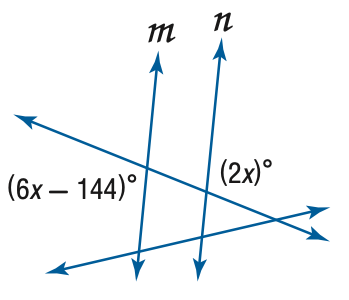Question: Find x so that m \parallel n.
Choices:
A. 18
B. 36
C. 38
D. 72
Answer with the letter. Answer: B 